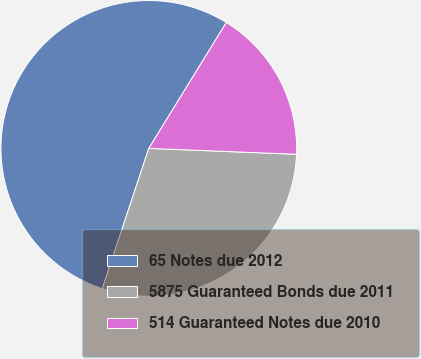Convert chart to OTSL. <chart><loc_0><loc_0><loc_500><loc_500><pie_chart><fcel>65 Notes due 2012<fcel>5875 Guaranteed Bonds due 2011<fcel>514 Guaranteed Notes due 2010<nl><fcel>53.69%<fcel>29.46%<fcel>16.85%<nl></chart> 